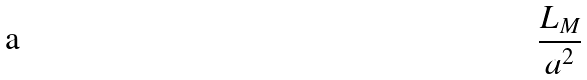<formula> <loc_0><loc_0><loc_500><loc_500>\frac { L _ { M } } { a ^ { 2 } }</formula> 